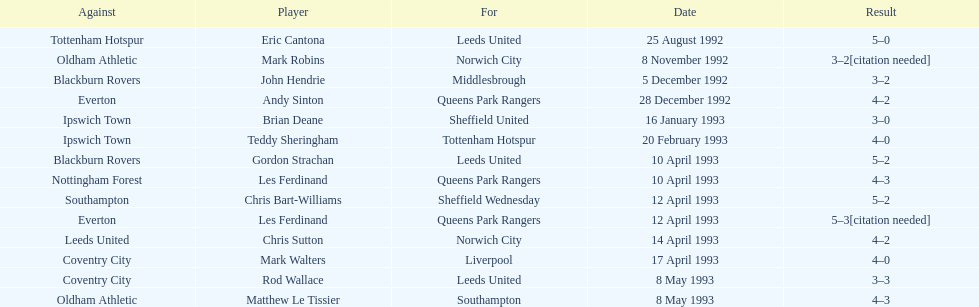In the 1992-1993 premier league, what was the total number of hat tricks scored by all players? 14. 